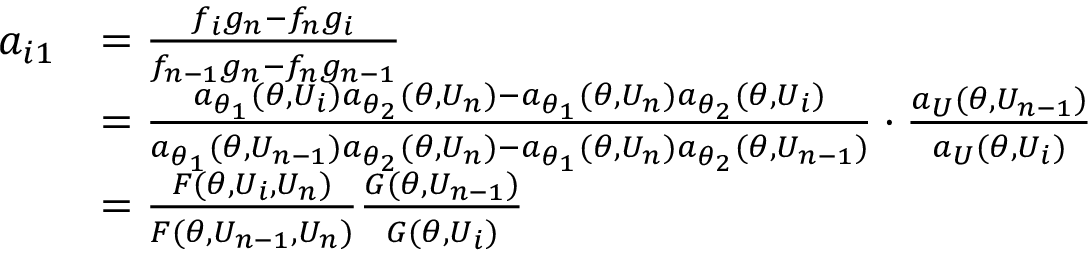Convert formula to latex. <formula><loc_0><loc_0><loc_500><loc_500>\begin{array} { r l } { a _ { i 1 } } & { = \frac { f _ { i } g _ { n } - f _ { n } g _ { i } } { f _ { n - 1 } g _ { n } - f _ { n } g _ { n - 1 } } } \\ & { = \frac { a _ { \theta _ { 1 } } ( \theta , U _ { i } ) a _ { \theta _ { 2 } } ( \theta , U _ { n } ) - a _ { \theta _ { 1 } } ( \theta , U _ { n } ) a _ { \theta _ { 2 } } ( \theta , U _ { i } ) } { a _ { \theta _ { 1 } } ( \theta , U _ { n - 1 } ) a _ { \theta _ { 2 } } ( \theta , U _ { n } ) - a _ { \theta _ { 1 } } ( \theta , U _ { n } ) a _ { \theta _ { 2 } } ( \theta , U _ { n - 1 } ) } \cdot \frac { a _ { U } ( \theta , U _ { n - 1 } ) } { a _ { U } ( \theta , U _ { i } ) } } \\ & { = \frac { F ( \theta , U _ { i } , U _ { n } ) } { F ( \theta , U _ { n - 1 } , U _ { n } ) } \frac { G ( \theta , U _ { n - 1 } ) } { G ( \theta , U _ { i } ) } } \end{array}</formula> 